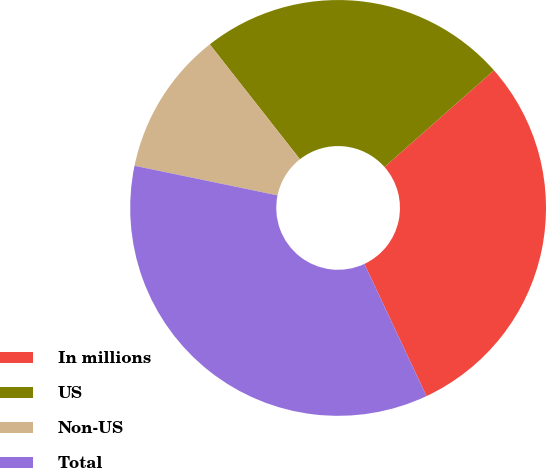Convert chart to OTSL. <chart><loc_0><loc_0><loc_500><loc_500><pie_chart><fcel>In millions<fcel>US<fcel>Non-US<fcel>Total<nl><fcel>29.52%<fcel>24.08%<fcel>11.16%<fcel>35.24%<nl></chart> 